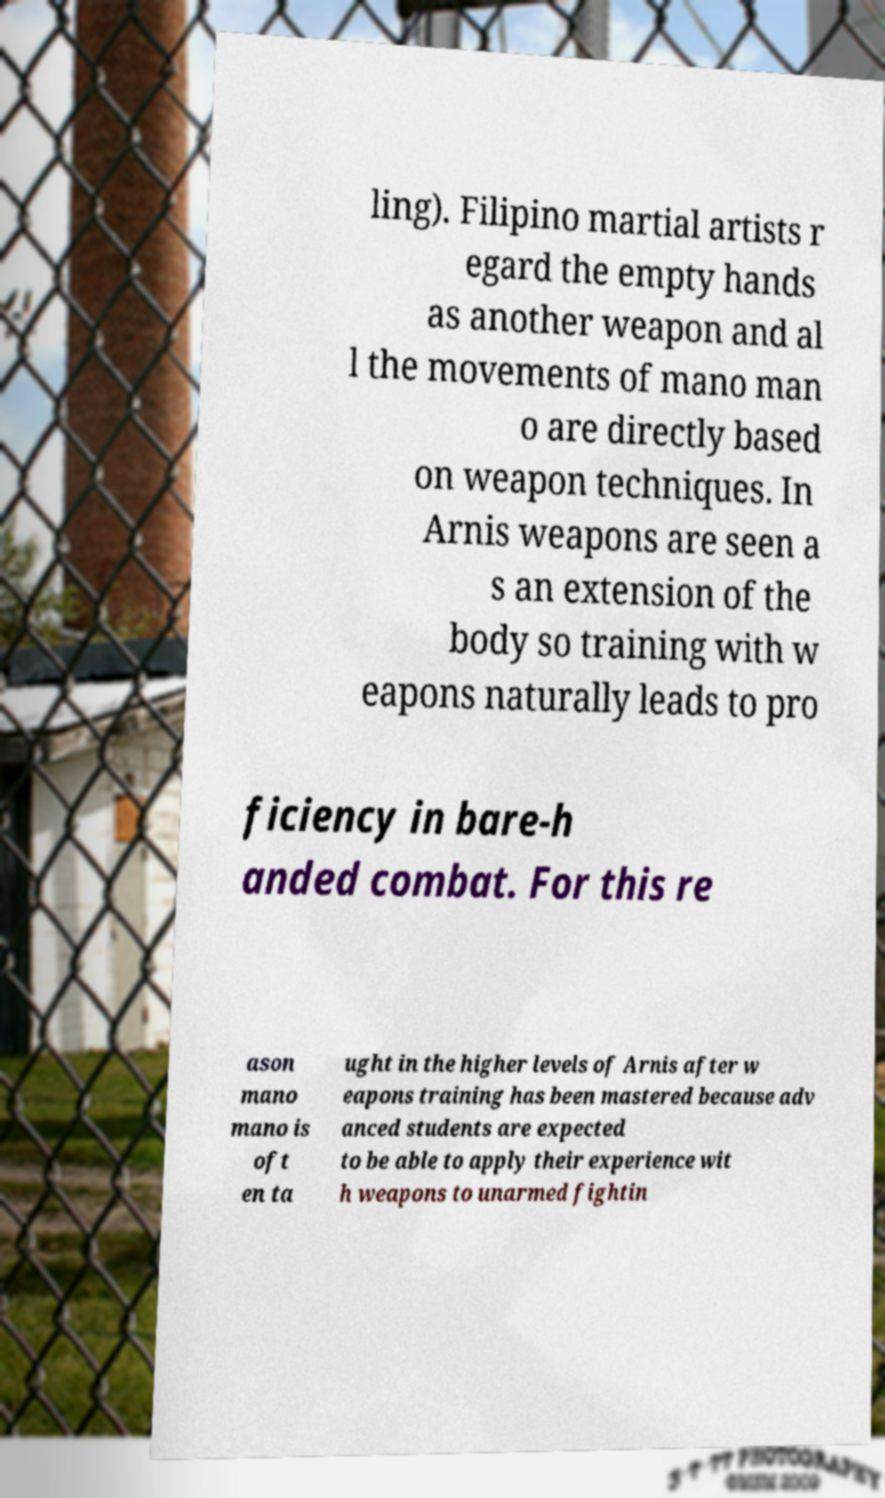There's text embedded in this image that I need extracted. Can you transcribe it verbatim? ling). Filipino martial artists r egard the empty hands as another weapon and al l the movements of mano man o are directly based on weapon techniques. In Arnis weapons are seen a s an extension of the body so training with w eapons naturally leads to pro ficiency in bare-h anded combat. For this re ason mano mano is oft en ta ught in the higher levels of Arnis after w eapons training has been mastered because adv anced students are expected to be able to apply their experience wit h weapons to unarmed fightin 